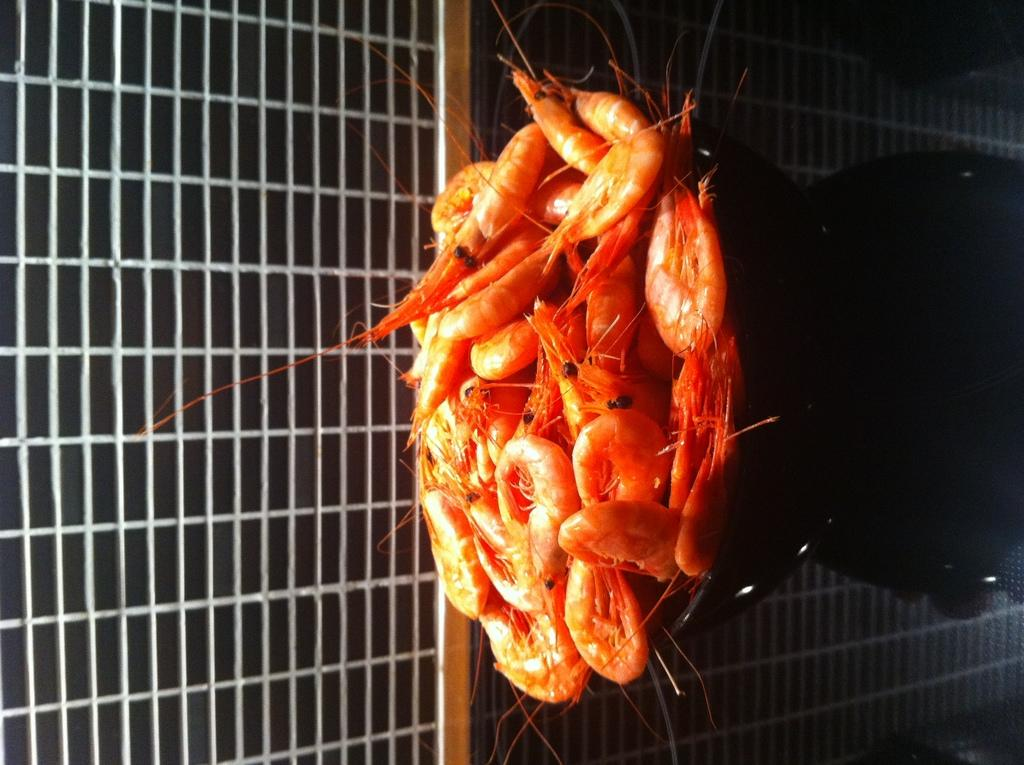What type of creatures can be seen in the image? There are insects in the image. Where are the insects located in relation to other objects? The insects are near fencing in the image. What else can be seen in the image besides the insects? There are covers in the image. What type of cows can be seen in the image? There are no cows present in the image; it features insects near fencing and covers. How does the fog affect the visibility of the insects in the image? There is no fog present in the image, so it does not affect the visibility of the insects. 